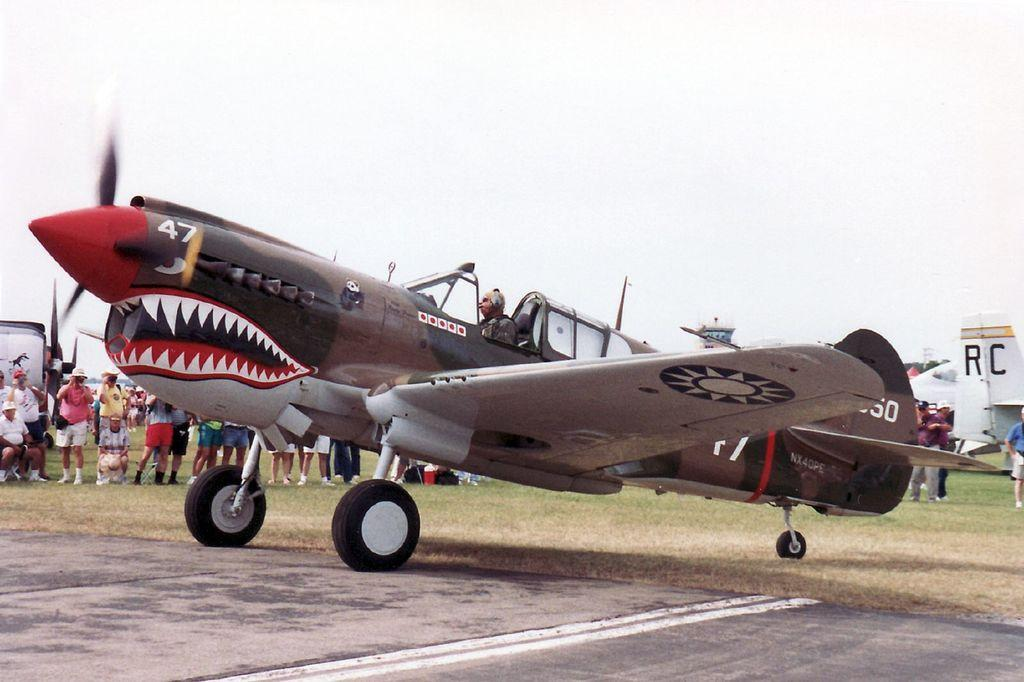<image>
Summarize the visual content of the image. A old fighter plane has the number 47 near its prop. 